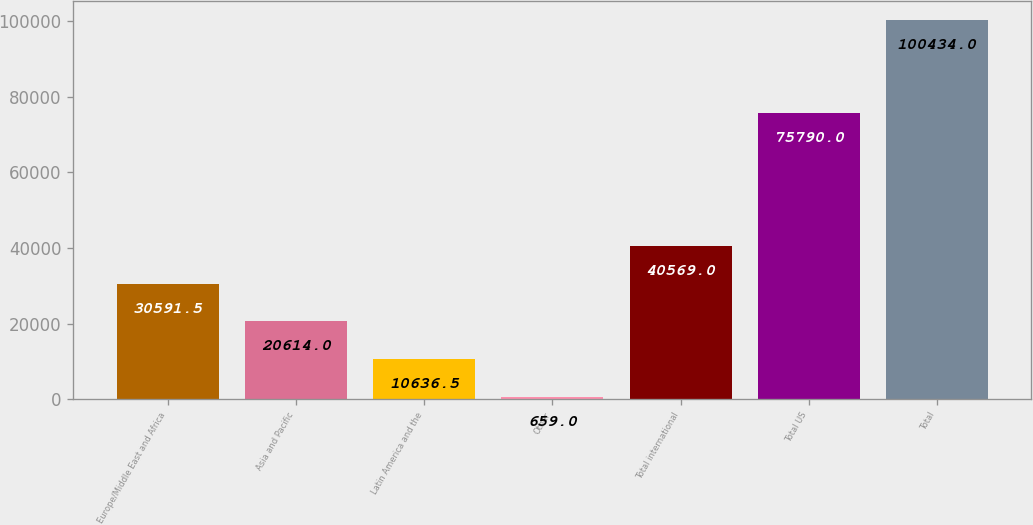Convert chart to OTSL. <chart><loc_0><loc_0><loc_500><loc_500><bar_chart><fcel>Europe/Middle East and Africa<fcel>Asia and Pacific<fcel>Latin America and the<fcel>Other<fcel>Total international<fcel>Total US<fcel>Total<nl><fcel>30591.5<fcel>20614<fcel>10636.5<fcel>659<fcel>40569<fcel>75790<fcel>100434<nl></chart> 